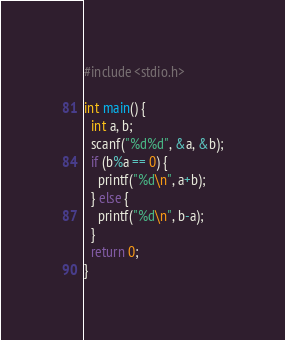Convert code to text. <code><loc_0><loc_0><loc_500><loc_500><_C_>#include <stdio.h>

int main() {
  int a, b;
  scanf("%d%d", &a, &b);
  if (b%a == 0) {
    printf("%d\n", a+b);
  } else {
    printf("%d\n", b-a);
  }
  return 0;
}
</code> 